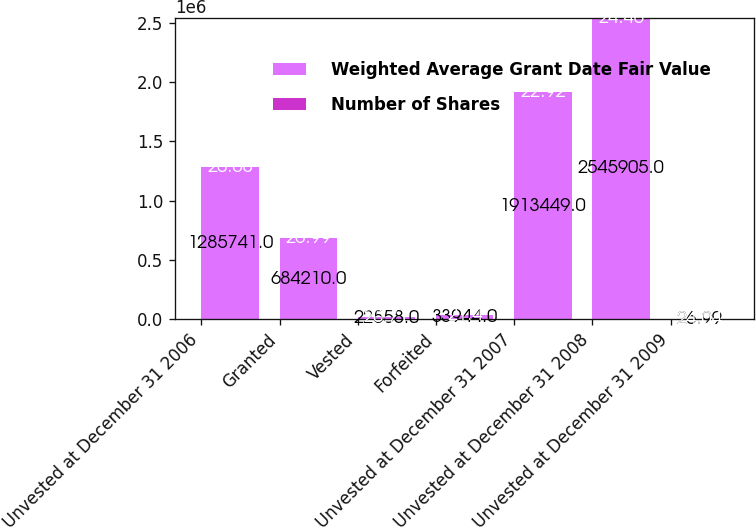Convert chart to OTSL. <chart><loc_0><loc_0><loc_500><loc_500><stacked_bar_chart><ecel><fcel>Unvested at December 31 2006<fcel>Granted<fcel>Vested<fcel>Forfeited<fcel>Unvested at December 31 2007<fcel>Unvested at December 31 2008<fcel>Unvested at December 31 2009<nl><fcel>Weighted Average Grant Date Fair Value<fcel>1.28574e+06<fcel>684210<fcel>22558<fcel>33944<fcel>1.91345e+06<fcel>2.5459e+06<fcel>26.99<nl><fcel>Number of Shares<fcel>20.68<fcel>26.99<fcel>20.71<fcel>21.4<fcel>22.92<fcel>24.46<fcel>24.04<nl></chart> 